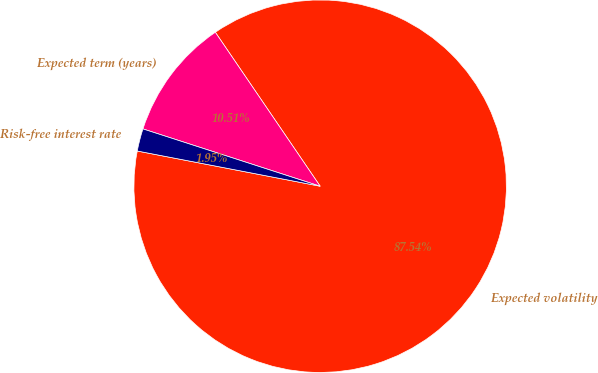Convert chart to OTSL. <chart><loc_0><loc_0><loc_500><loc_500><pie_chart><fcel>Expected volatility<fcel>Expected term (years)<fcel>Risk-free interest rate<nl><fcel>87.55%<fcel>10.51%<fcel>1.95%<nl></chart> 